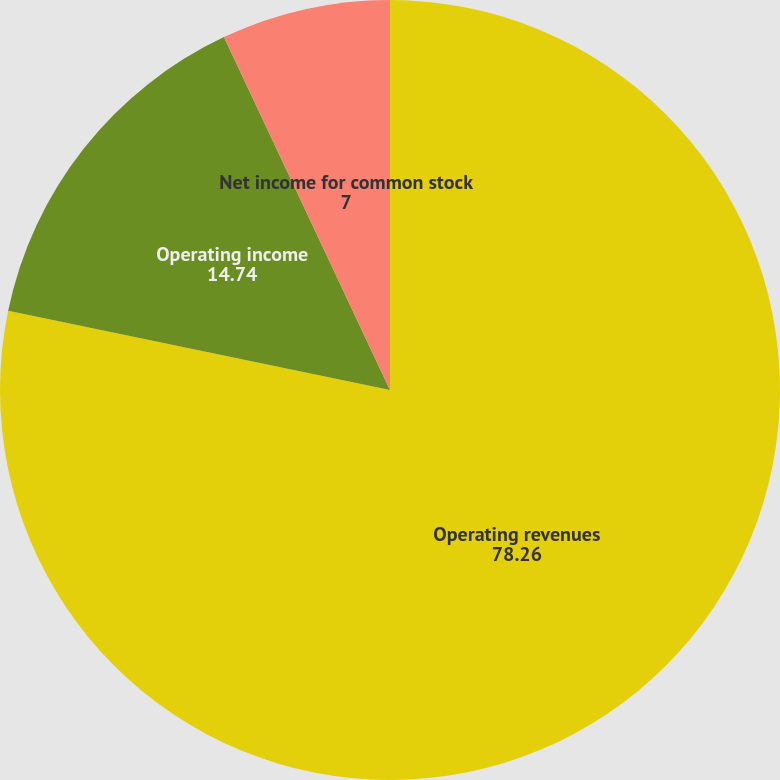Convert chart to OTSL. <chart><loc_0><loc_0><loc_500><loc_500><pie_chart><fcel>Operating revenues<fcel>Operating income<fcel>Net income for common stock<nl><fcel>78.26%<fcel>14.74%<fcel>7.0%<nl></chart> 